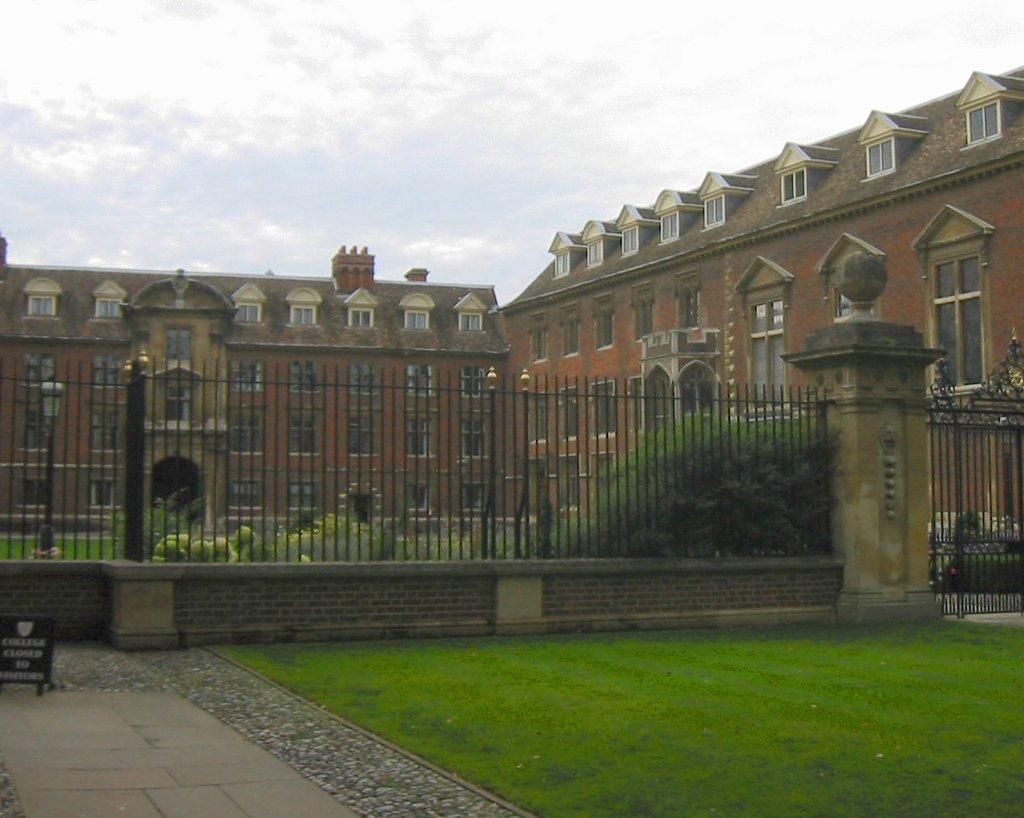Please provide a concise description of this image. In this image we can see grass on the ground, board on the surface, wall, fence and gate. In the background we can see plants, building, windows and clouds in the sky. 